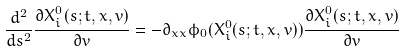<formula> <loc_0><loc_0><loc_500><loc_500>\frac { d ^ { 2 } } { d s ^ { 2 } } \frac { \partial X _ { i } ^ { 0 } ( s ; t , x , v ) } { \partial v } = - \partial _ { x x } \phi _ { 0 } ( X _ { i } ^ { 0 } ( s ; t , x , v ) ) \frac { \partial X _ { i } ^ { 0 } ( s ; t , x , v ) } { \partial v }</formula> 